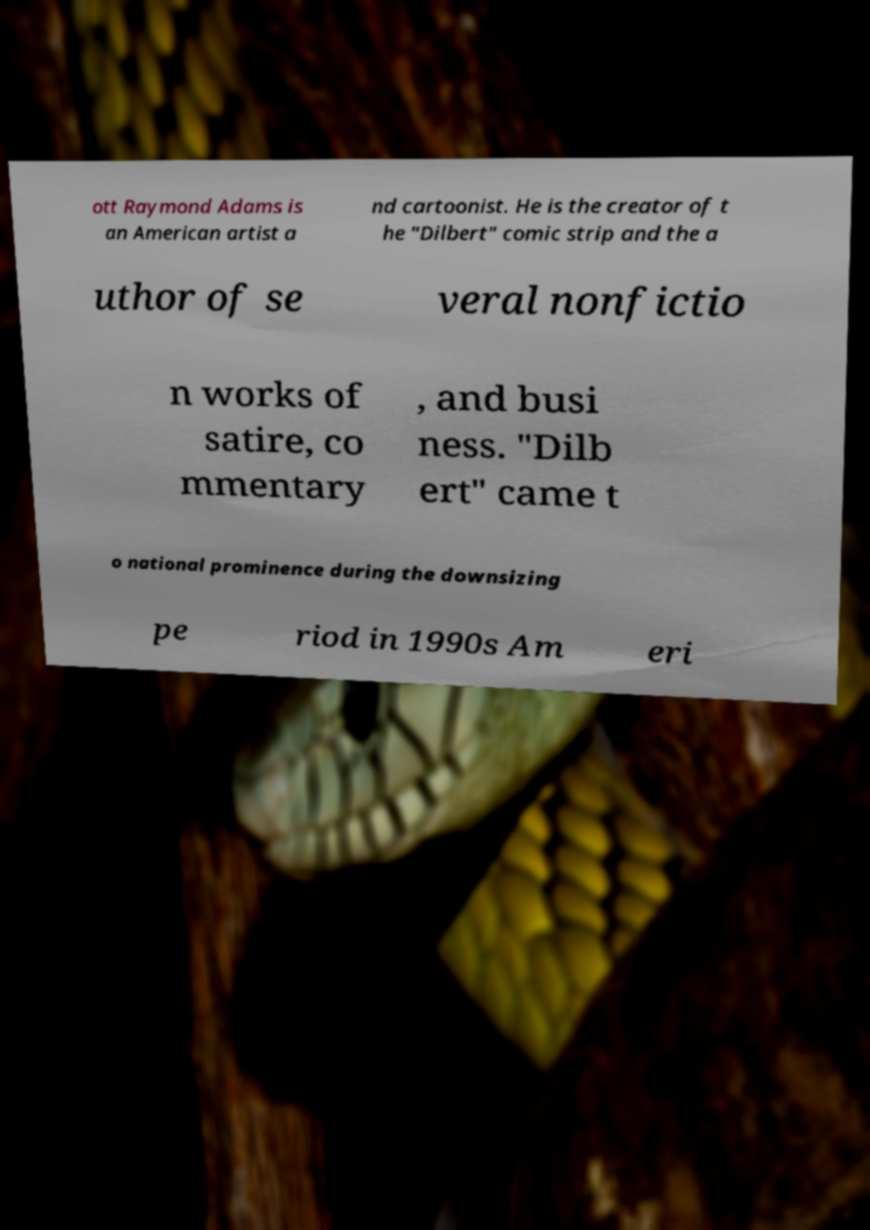There's text embedded in this image that I need extracted. Can you transcribe it verbatim? ott Raymond Adams is an American artist a nd cartoonist. He is the creator of t he "Dilbert" comic strip and the a uthor of se veral nonfictio n works of satire, co mmentary , and busi ness. "Dilb ert" came t o national prominence during the downsizing pe riod in 1990s Am eri 